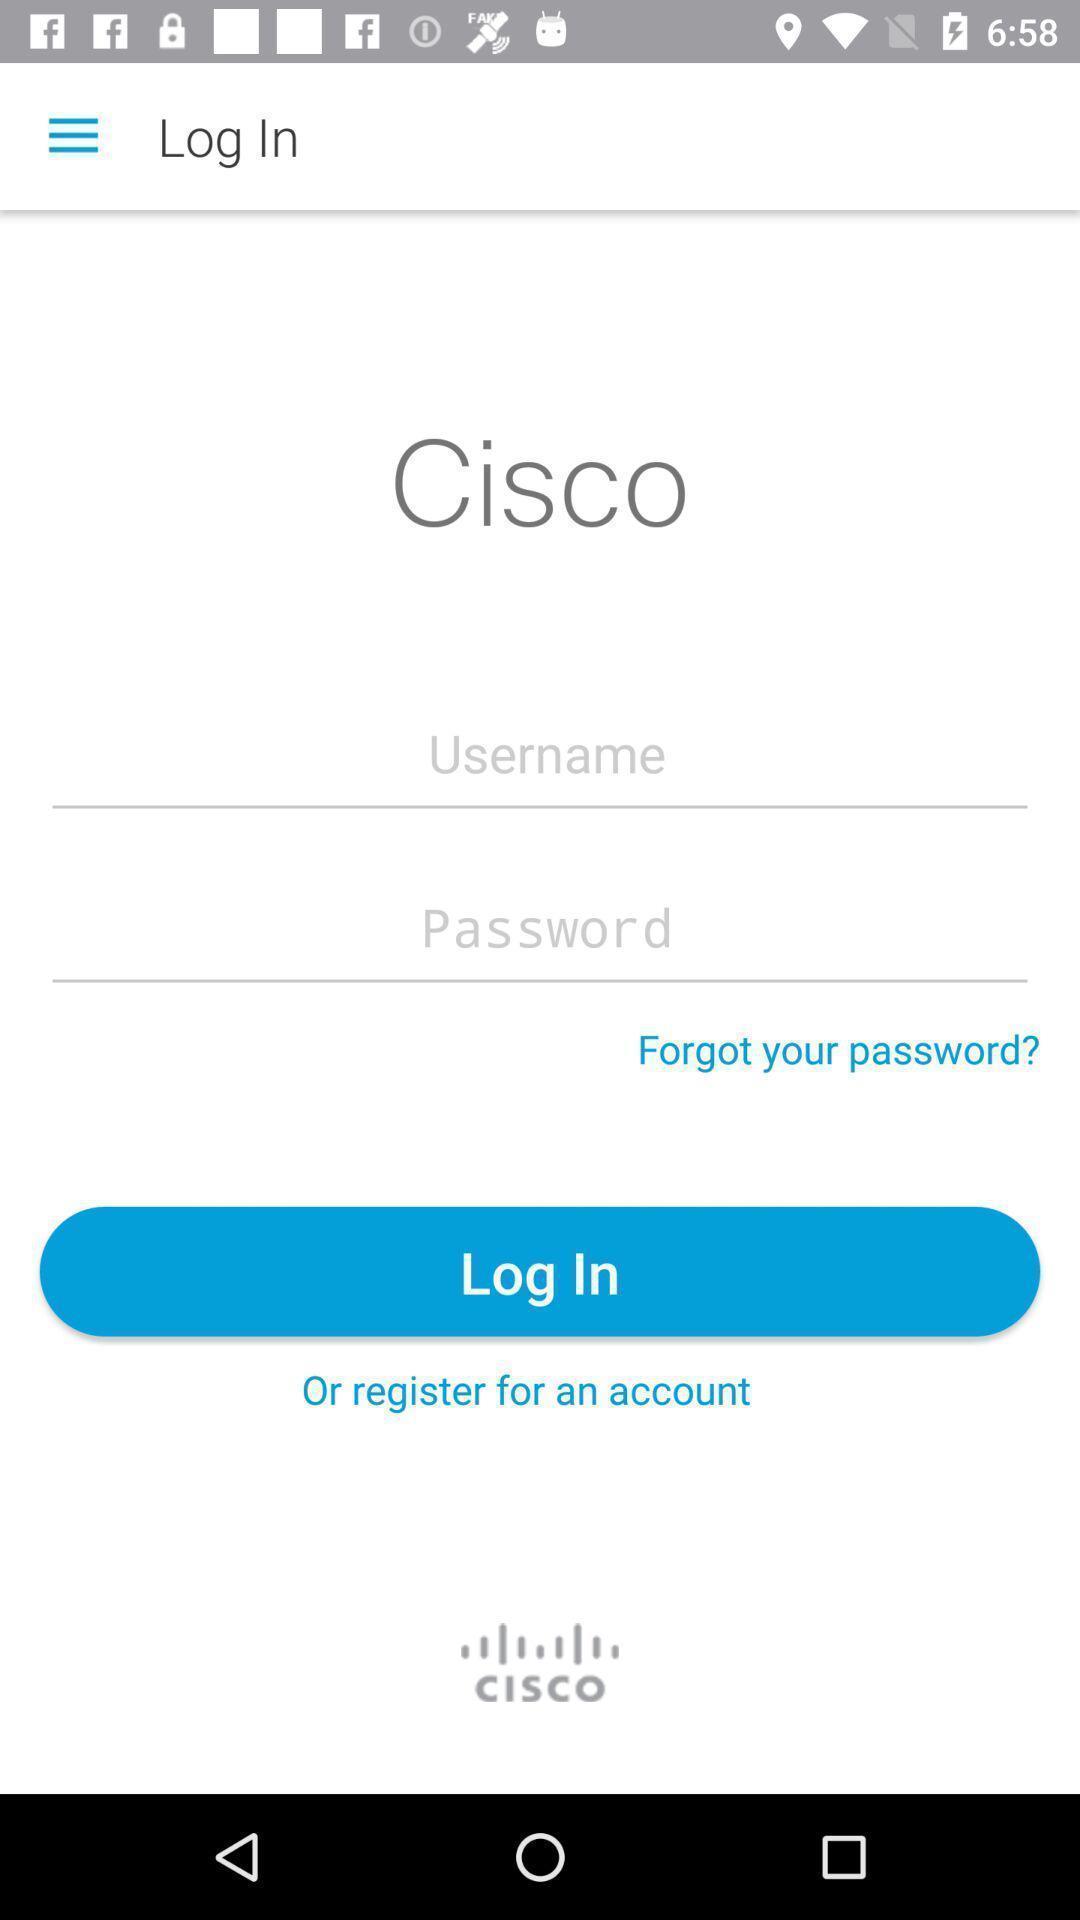Explain what's happening in this screen capture. Screen displaying login page. 